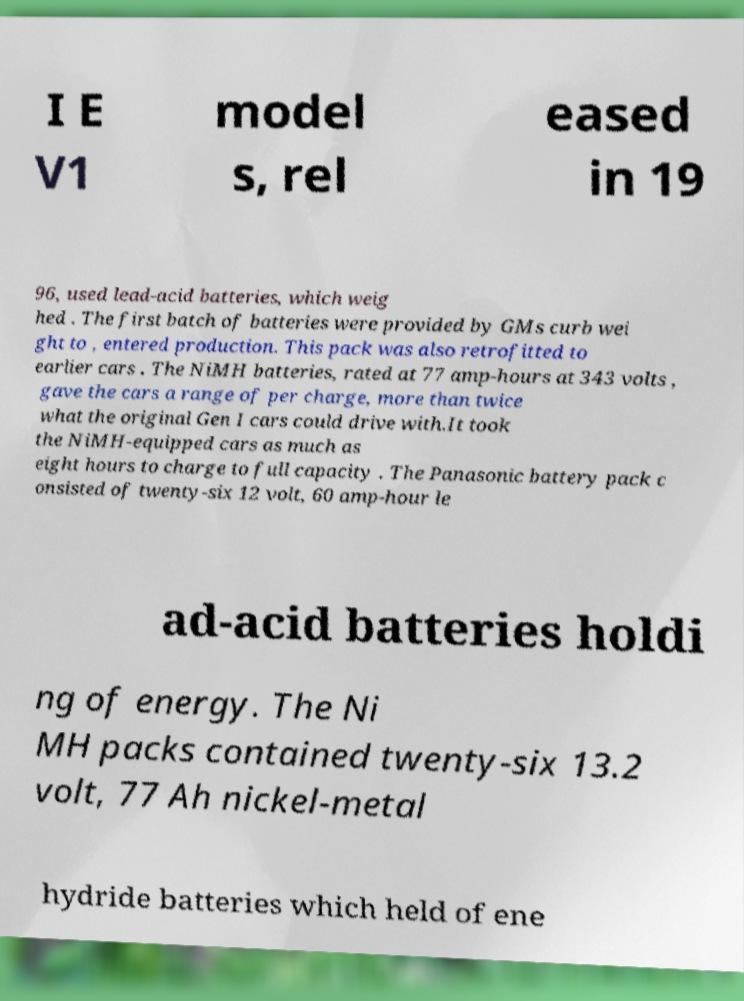What messages or text are displayed in this image? I need them in a readable, typed format. I E V1 model s, rel eased in 19 96, used lead-acid batteries, which weig hed . The first batch of batteries were provided by GMs curb wei ght to , entered production. This pack was also retrofitted to earlier cars . The NiMH batteries, rated at 77 amp-hours at 343 volts , gave the cars a range of per charge, more than twice what the original Gen I cars could drive with.It took the NiMH-equipped cars as much as eight hours to charge to full capacity . The Panasonic battery pack c onsisted of twenty-six 12 volt, 60 amp-hour le ad-acid batteries holdi ng of energy. The Ni MH packs contained twenty-six 13.2 volt, 77 Ah nickel-metal hydride batteries which held of ene 